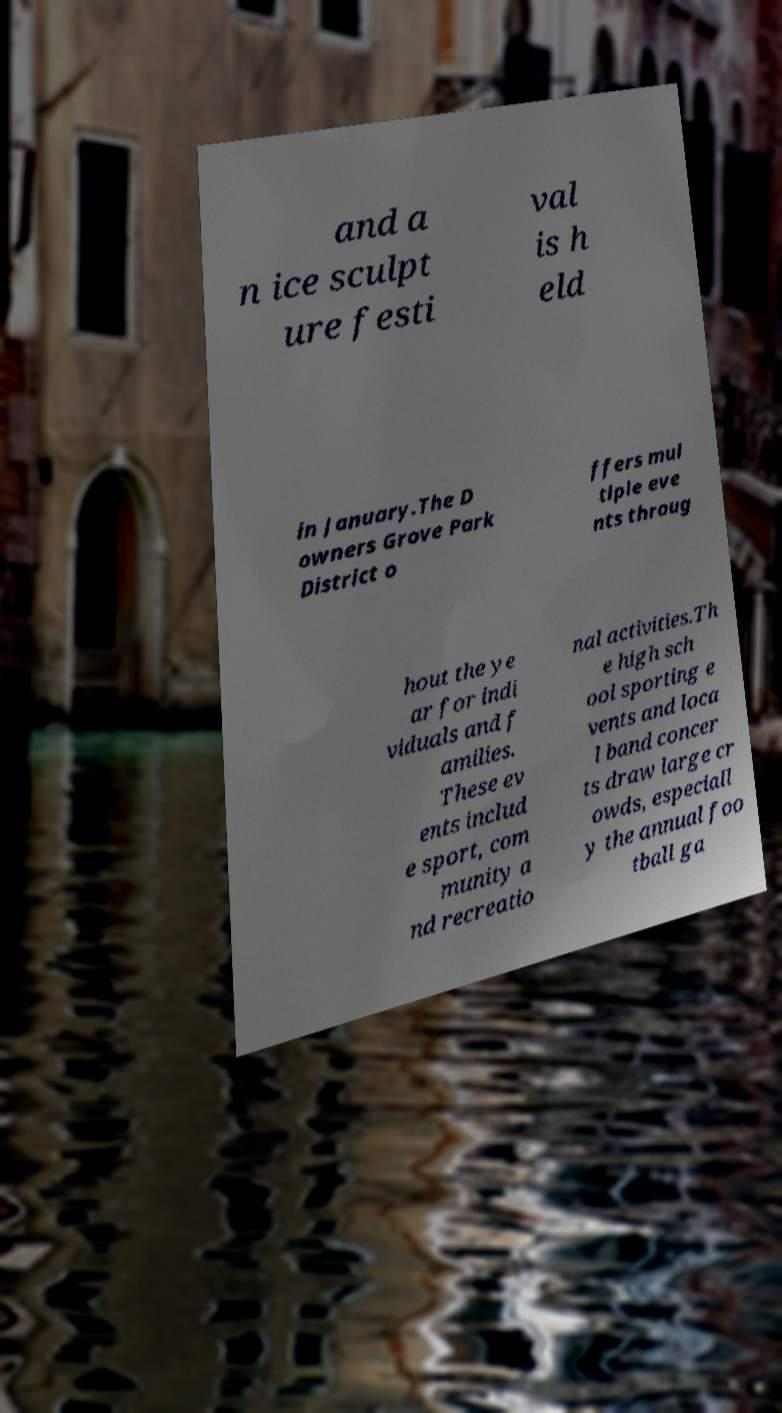Please read and relay the text visible in this image. What does it say? and a n ice sculpt ure festi val is h eld in January.The D owners Grove Park District o ffers mul tiple eve nts throug hout the ye ar for indi viduals and f amilies. These ev ents includ e sport, com munity a nd recreatio nal activities.Th e high sch ool sporting e vents and loca l band concer ts draw large cr owds, especiall y the annual foo tball ga 